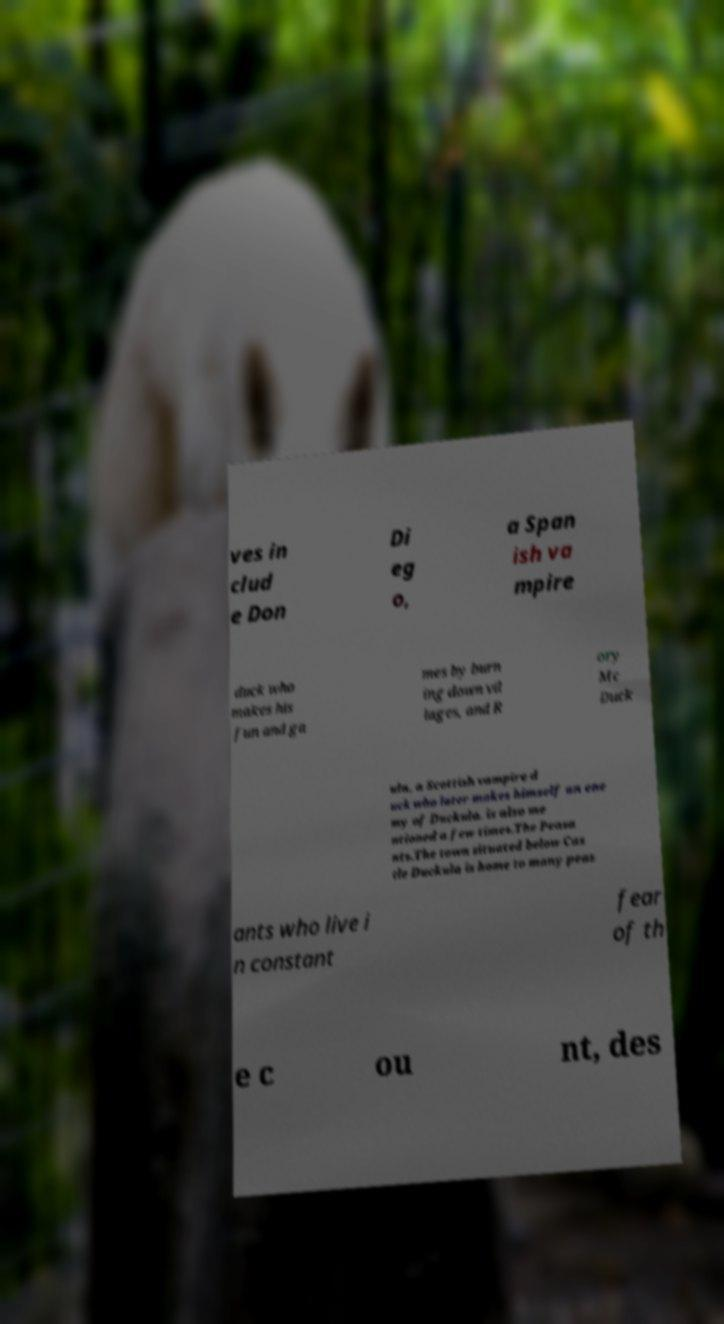Could you assist in decoding the text presented in this image and type it out clearly? ves in clud e Don Di eg o, a Span ish va mpire duck who makes his fun and ga mes by burn ing down vil lages, and R ory Mc Duck ula, a Scottish vampire d uck who later makes himself an ene my of Duckula. is also me ntioned a few times.The Peasa nts.The town situated below Cas tle Duckula is home to many peas ants who live i n constant fear of th e c ou nt, des 